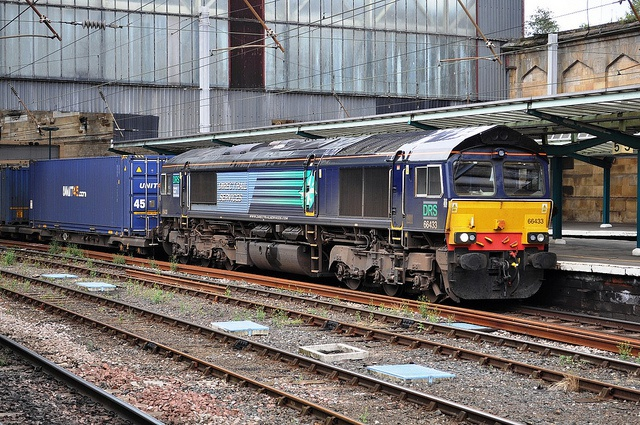Describe the objects in this image and their specific colors. I can see a train in gray, black, navy, and darkgray tones in this image. 